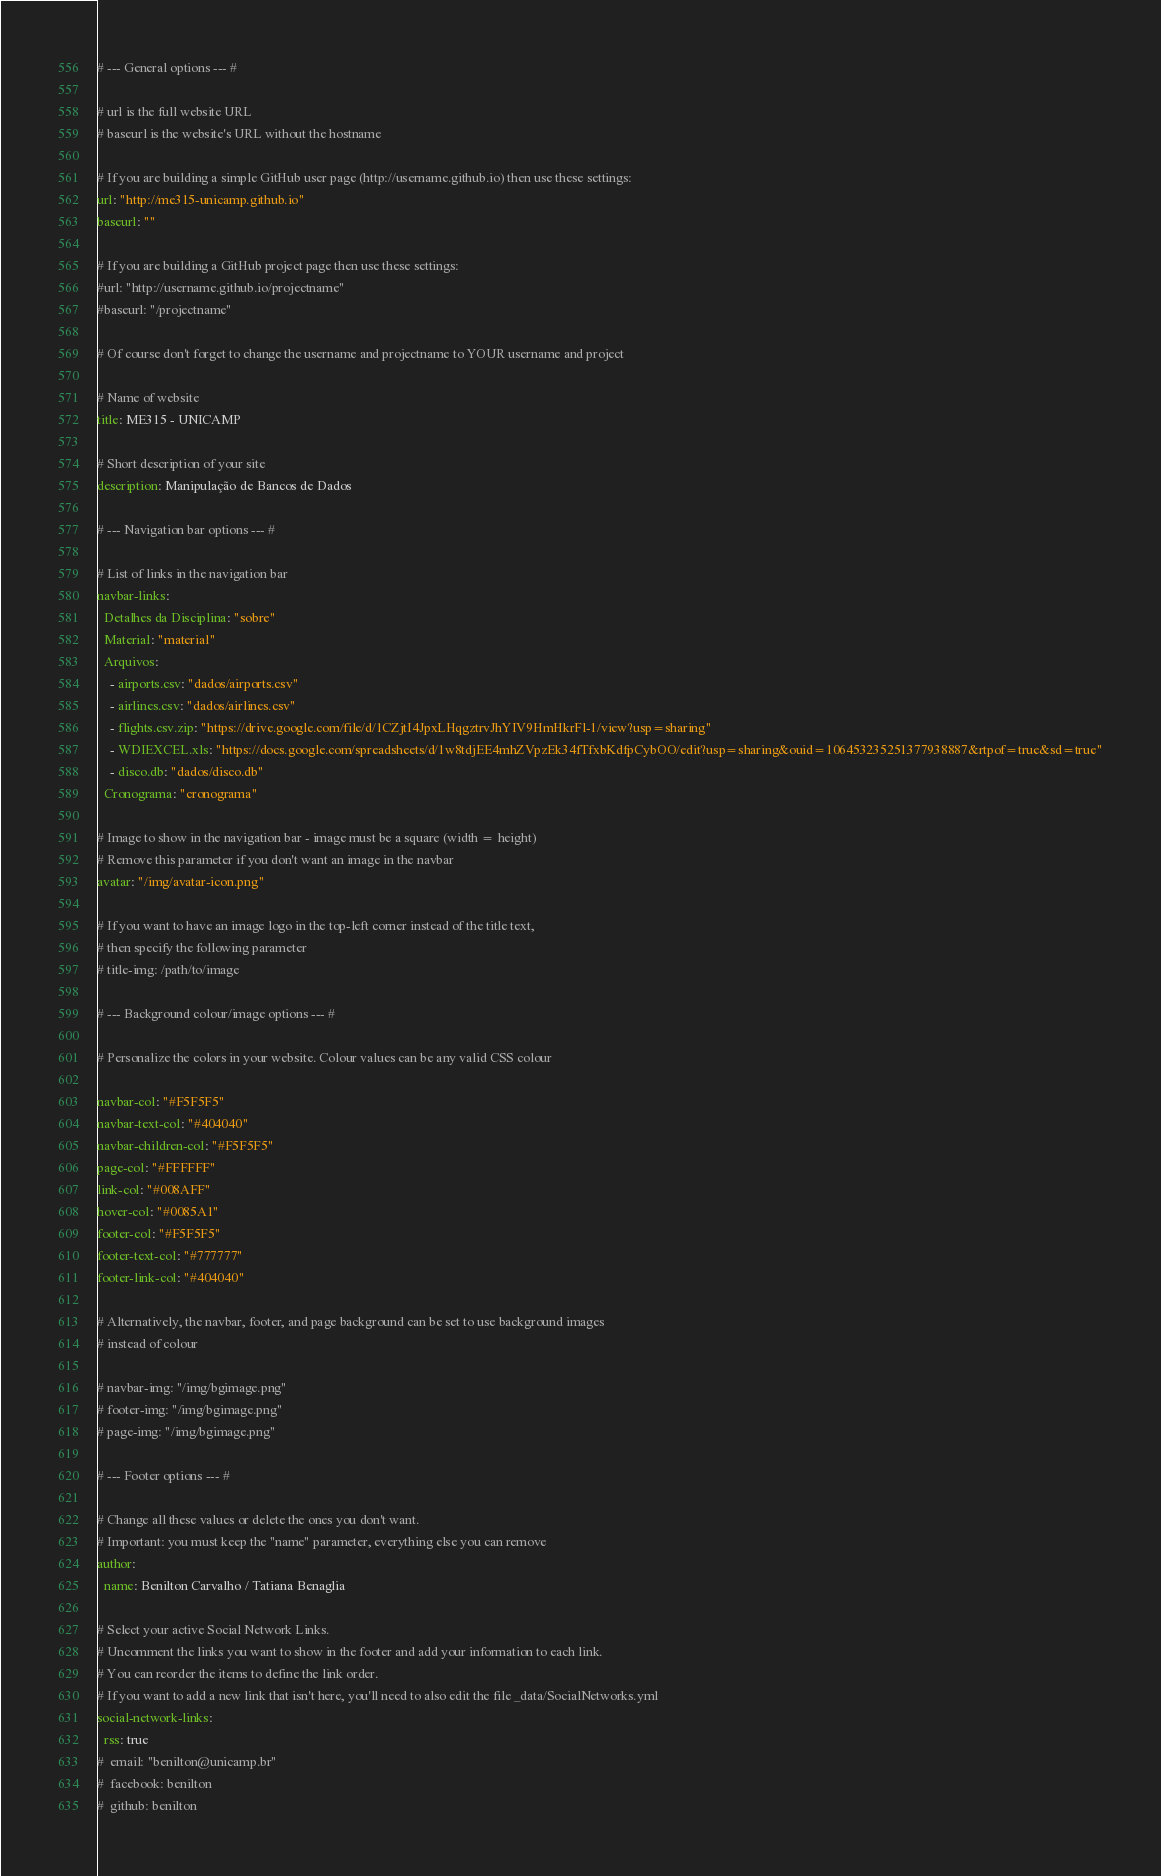Convert code to text. <code><loc_0><loc_0><loc_500><loc_500><_YAML_># --- General options --- #

# url is the full website URL
# baseurl is the website's URL without the hostname

# If you are building a simple GitHub user page (http://username.github.io) then use these settings:
url: "http://me315-unicamp.github.io"
baseurl: ""

# If you are building a GitHub project page then use these settings:
#url: "http://username.github.io/projectname"
#baseurl: "/projectname"

# Of course don't forget to change the username and projectname to YOUR username and project

# Name of website
title: ME315 - UNICAMP

# Short description of your site
description: Manipulação de Bancos de Dados

# --- Navigation bar options --- #

# List of links in the navigation bar
navbar-links:
  Detalhes da Disciplina: "sobre"
  Material: "material"
  Arquivos:
    - airports.csv: "dados/airports.csv"
    - airlines.csv: "dados/airlines.csv"
    - flights.csv.zip: "https://drive.google.com/file/d/1CZjtI4JpxLHqgztrvJhYIV9HmHkrFl-1/view?usp=sharing"
    - WDIEXCEL.xls: "https://docs.google.com/spreadsheets/d/1w8tdjEE4mhZVpzEk34fTfxbKdfpCybOO/edit?usp=sharing&ouid=106453235251377938887&rtpof=true&sd=true"
    - disco.db: "dados/disco.db"
  Cronograma: "cronograma"

# Image to show in the navigation bar - image must be a square (width = height)
# Remove this parameter if you don't want an image in the navbar
avatar: "/img/avatar-icon.png"

# If you want to have an image logo in the top-left corner instead of the title text,
# then specify the following parameter
# title-img: /path/to/image

# --- Background colour/image options --- #

# Personalize the colors in your website. Colour values can be any valid CSS colour

navbar-col: "#F5F5F5"
navbar-text-col: "#404040"
navbar-children-col: "#F5F5F5"
page-col: "#FFFFFF"
link-col: "#008AFF"
hover-col: "#0085A1"
footer-col: "#F5F5F5"
footer-text-col: "#777777"
footer-link-col: "#404040"

# Alternatively, the navbar, footer, and page background can be set to use background images
# instead of colour

# navbar-img: "/img/bgimage.png"
# footer-img: "/img/bgimage.png"
# page-img: "/img/bgimage.png"

# --- Footer options --- #

# Change all these values or delete the ones you don't want.
# Important: you must keep the "name" parameter, everything else you can remove
author:
  name: Benilton Carvalho / Tatiana Benaglia

# Select your active Social Network Links.
# Uncomment the links you want to show in the footer and add your information to each link.
# You can reorder the items to define the link order.
# If you want to add a new link that isn't here, you'll need to also edit the file _data/SocialNetworks.yml
social-network-links:
  rss: true
#  email: "benilton@unicamp.br"
#  facebook: benilton
#  github: benilton</code> 